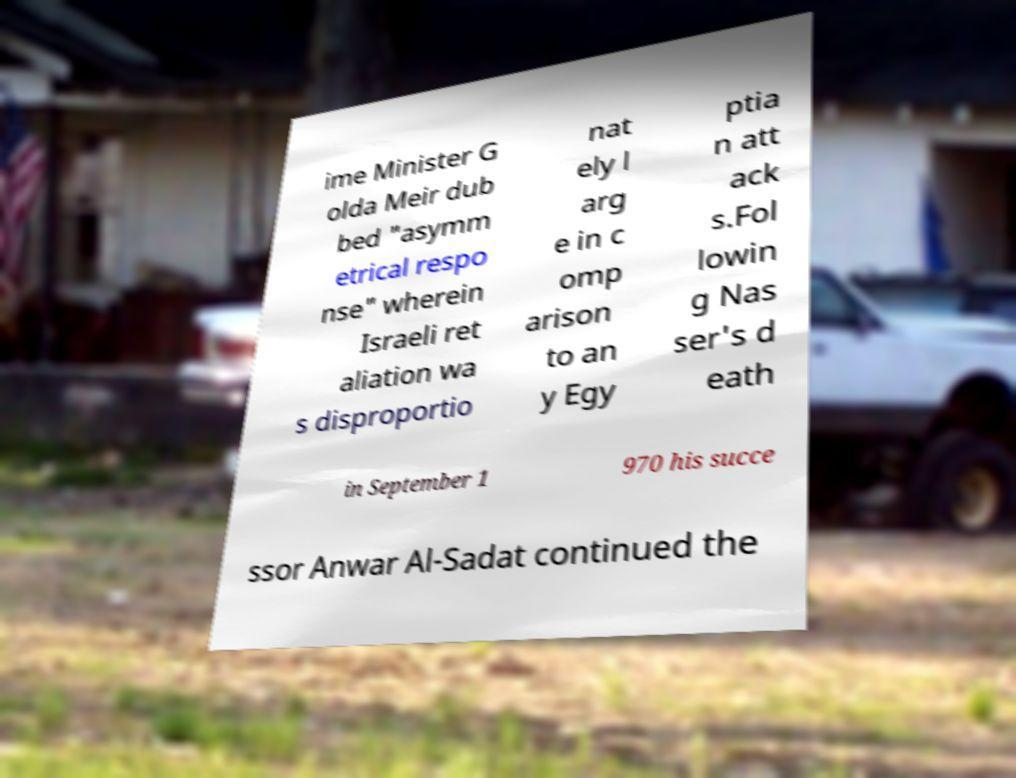For documentation purposes, I need the text within this image transcribed. Could you provide that? ime Minister G olda Meir dub bed "asymm etrical respo nse" wherein Israeli ret aliation wa s disproportio nat ely l arg e in c omp arison to an y Egy ptia n att ack s.Fol lowin g Nas ser's d eath in September 1 970 his succe ssor Anwar Al-Sadat continued the 